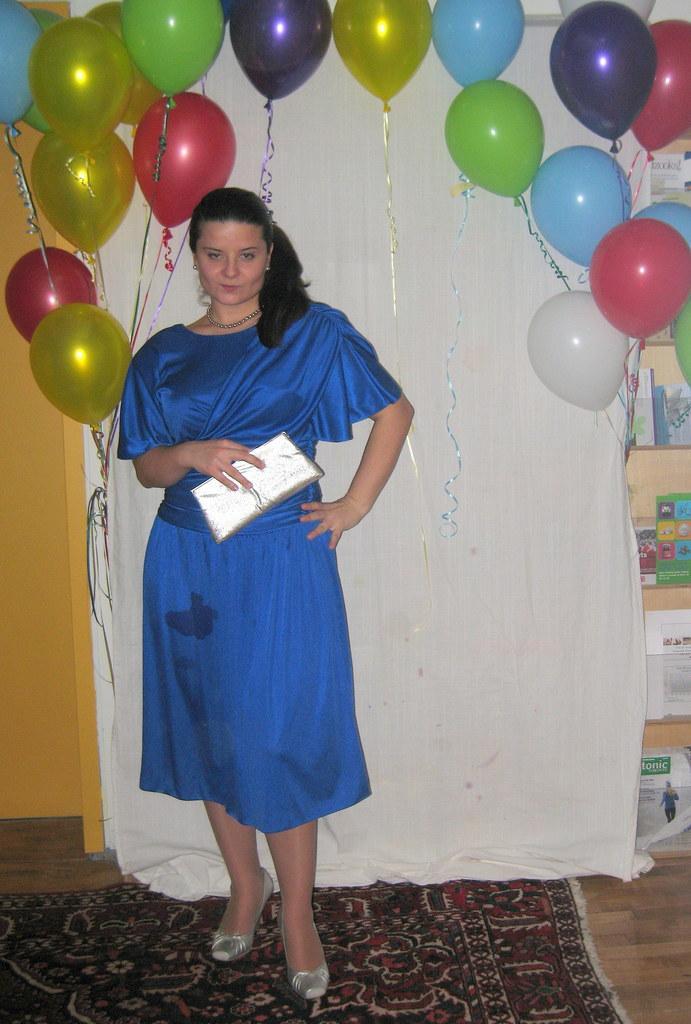In one or two sentences, can you explain what this image depicts? A beautiful woman is standing, she wore blue color dress. Behind her there are balloons. 